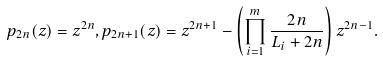Convert formula to latex. <formula><loc_0><loc_0><loc_500><loc_500>p _ { 2 n } ( z ) = z ^ { 2 n } , p _ { 2 n + 1 } ( z ) = z ^ { 2 n + 1 } - \left ( \prod _ { i = 1 } ^ { m } \frac { 2 n } { L _ { i } + 2 n } \right ) z ^ { 2 n - 1 } .</formula> 